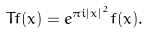Convert formula to latex. <formula><loc_0><loc_0><loc_500><loc_500>T f ( x ) = e ^ { \pi i | x | ^ { 2 } } f ( x ) .</formula> 